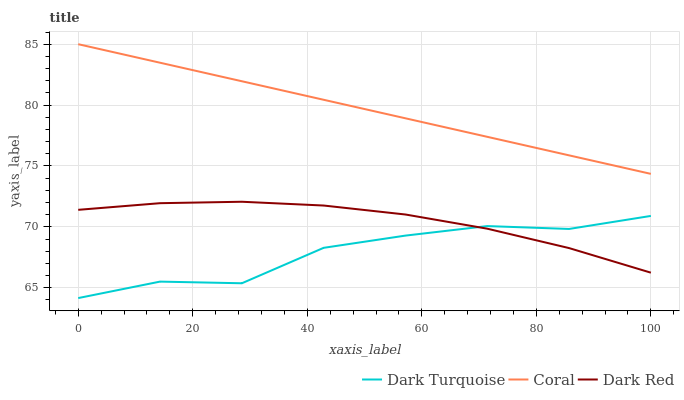Does Dark Turquoise have the minimum area under the curve?
Answer yes or no. Yes. Does Coral have the maximum area under the curve?
Answer yes or no. Yes. Does Dark Red have the minimum area under the curve?
Answer yes or no. No. Does Dark Red have the maximum area under the curve?
Answer yes or no. No. Is Coral the smoothest?
Answer yes or no. Yes. Is Dark Turquoise the roughest?
Answer yes or no. Yes. Is Dark Red the smoothest?
Answer yes or no. No. Is Dark Red the roughest?
Answer yes or no. No. Does Dark Turquoise have the lowest value?
Answer yes or no. Yes. Does Dark Red have the lowest value?
Answer yes or no. No. Does Coral have the highest value?
Answer yes or no. Yes. Does Dark Red have the highest value?
Answer yes or no. No. Is Dark Red less than Coral?
Answer yes or no. Yes. Is Coral greater than Dark Turquoise?
Answer yes or no. Yes. Does Dark Red intersect Dark Turquoise?
Answer yes or no. Yes. Is Dark Red less than Dark Turquoise?
Answer yes or no. No. Is Dark Red greater than Dark Turquoise?
Answer yes or no. No. Does Dark Red intersect Coral?
Answer yes or no. No. 